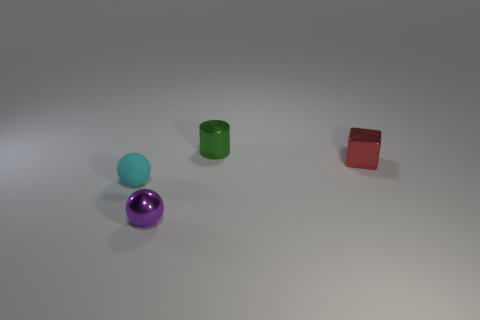Add 3 tiny rubber cylinders. How many objects exist? 7 Subtract all cylinders. How many objects are left? 3 Add 4 green things. How many green things are left? 5 Add 2 green objects. How many green objects exist? 3 Subtract 1 cyan balls. How many objects are left? 3 Subtract all purple spheres. Subtract all tiny gray shiny spheres. How many objects are left? 3 